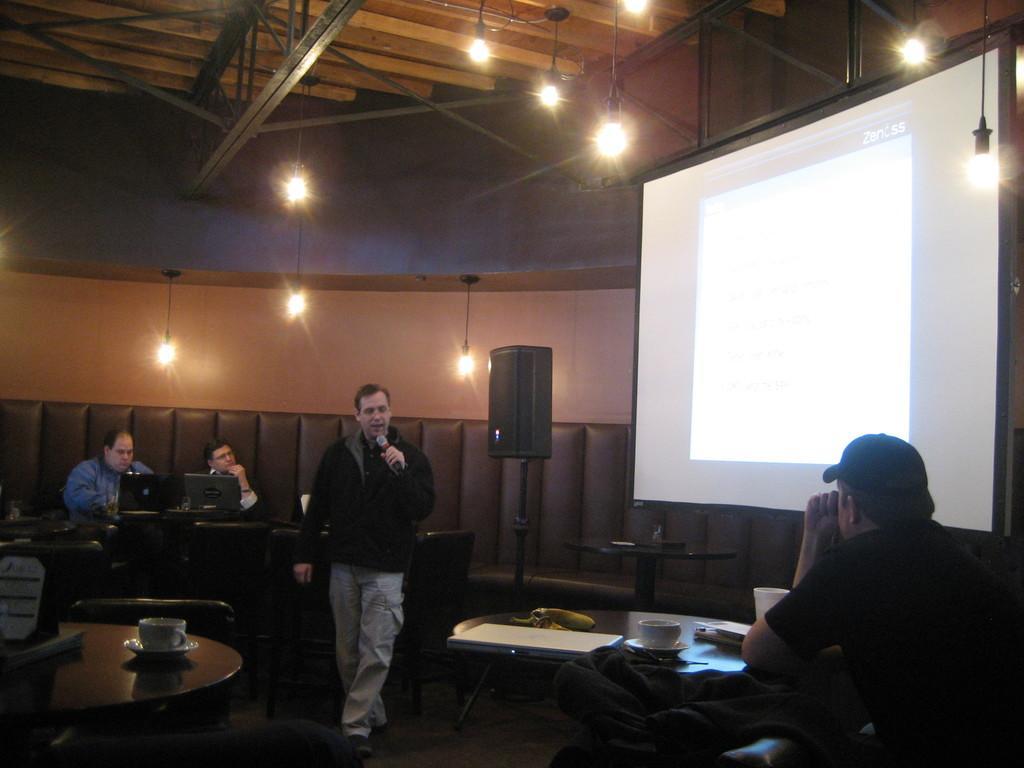Can you describe this image briefly? This image is clicked inside a room. There are people sitting on the chairs at the tables. In the center there is a man walking and holding a microphone in his hand. On the tables there are cup and saucers and laptops. There are lights hanging to the ceiling. To the right there is a projector board. 